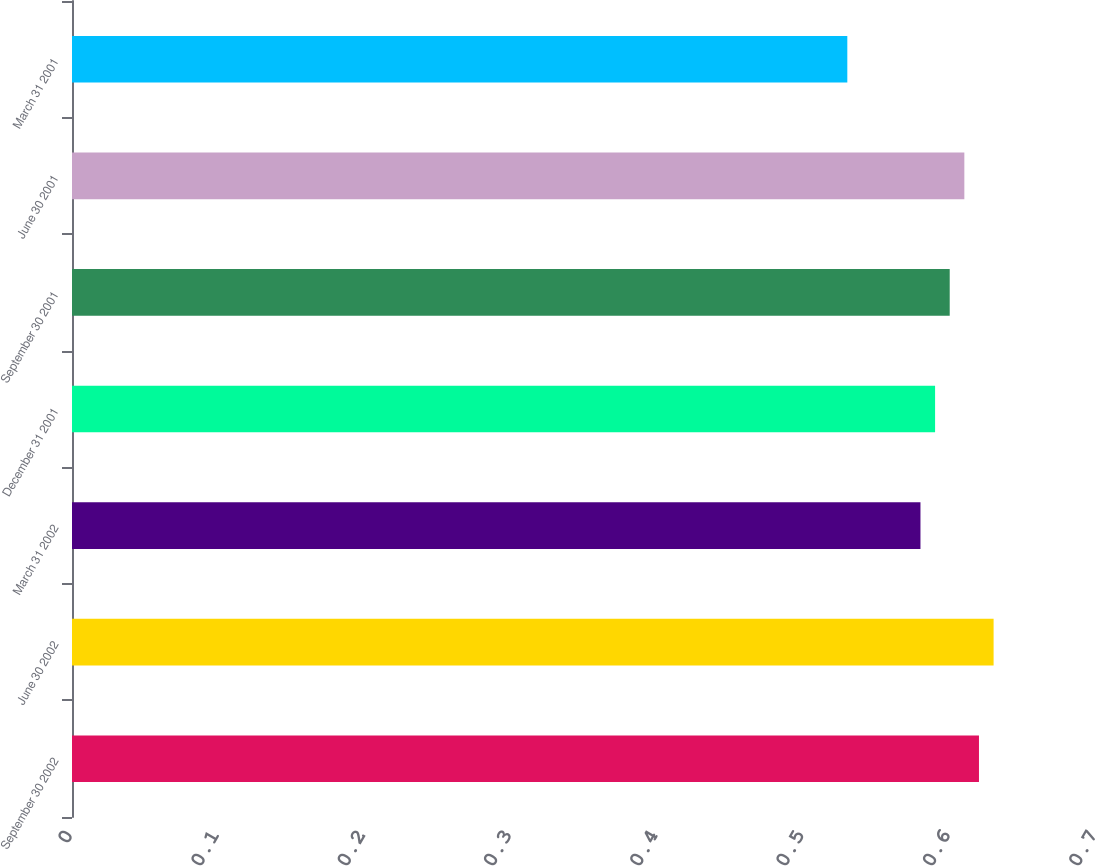Convert chart. <chart><loc_0><loc_0><loc_500><loc_500><bar_chart><fcel>September 30 2002<fcel>June 30 2002<fcel>March 31 2002<fcel>December 31 2001<fcel>September 30 2001<fcel>June 30 2001<fcel>March 31 2001<nl><fcel>0.62<fcel>0.63<fcel>0.58<fcel>0.59<fcel>0.6<fcel>0.61<fcel>0.53<nl></chart> 